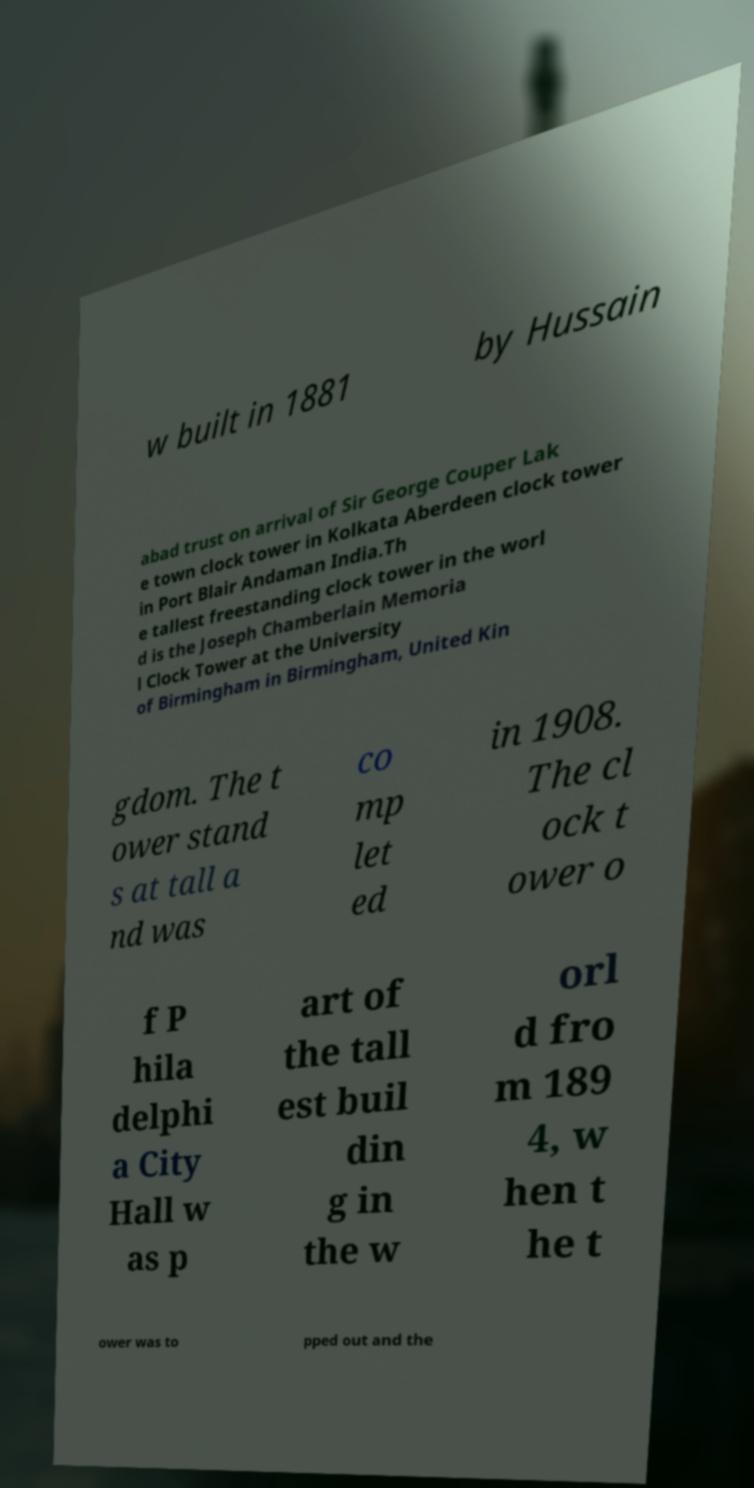Could you assist in decoding the text presented in this image and type it out clearly? w built in 1881 by Hussain abad trust on arrival of Sir George Couper Lak e town clock tower in Kolkata Aberdeen clock tower in Port Blair Andaman India.Th e tallest freestanding clock tower in the worl d is the Joseph Chamberlain Memoria l Clock Tower at the University of Birmingham in Birmingham, United Kin gdom. The t ower stand s at tall a nd was co mp let ed in 1908. The cl ock t ower o f P hila delphi a City Hall w as p art of the tall est buil din g in the w orl d fro m 189 4, w hen t he t ower was to pped out and the 